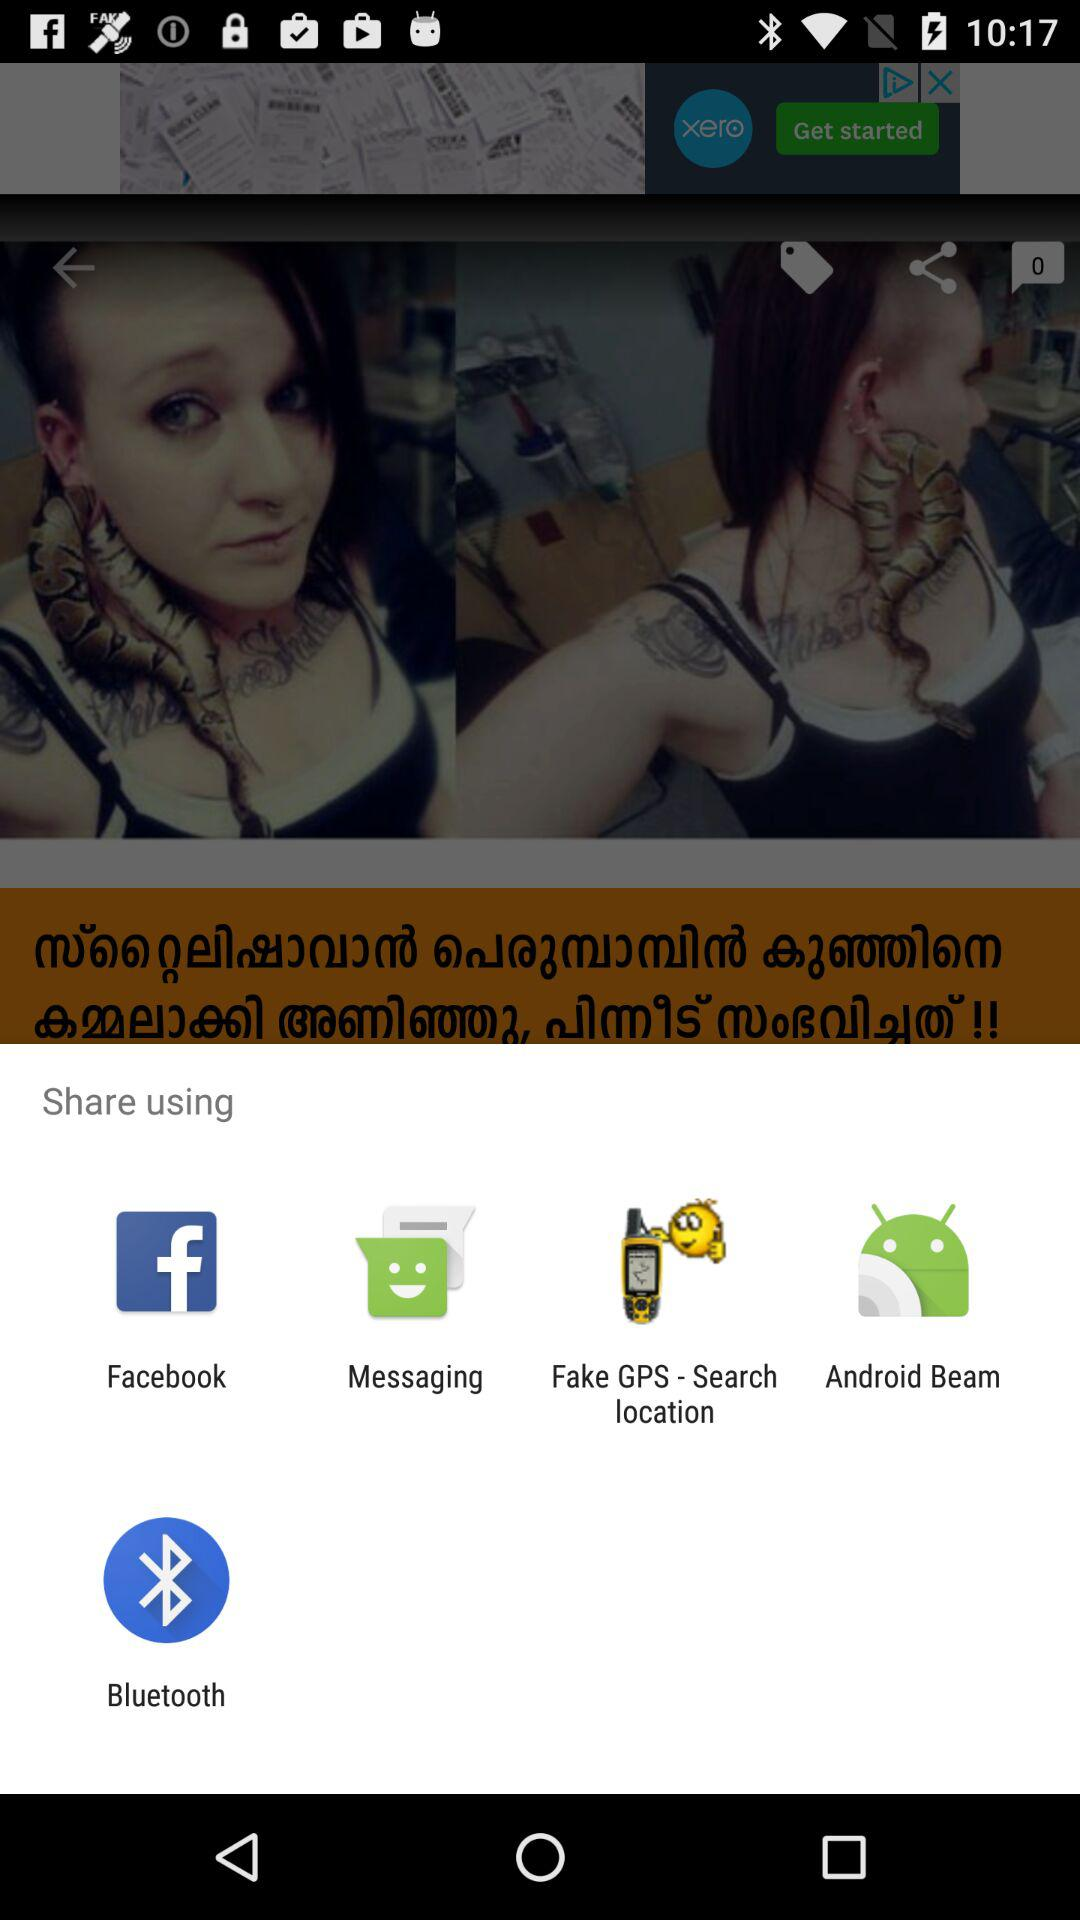What apps are there for sharing? There are "Facebook", "Messaging", "Fake GPS-Search location", "Android Beam", and "Bluetooth" for sharing. 